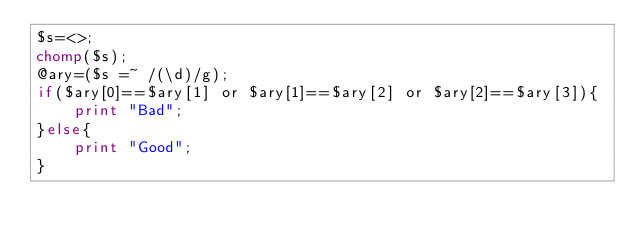<code> <loc_0><loc_0><loc_500><loc_500><_Perl_>$s=<>;
chomp($s);
@ary=($s =~ /(\d)/g);
if($ary[0]==$ary[1] or $ary[1]==$ary[2] or $ary[2]==$ary[3]){
	print "Bad";
}else{
	print "Good";
}</code> 